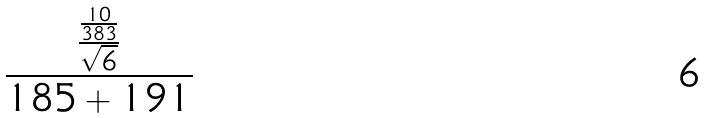<formula> <loc_0><loc_0><loc_500><loc_500>\frac { \frac { \frac { 1 0 } { 3 8 3 } } { \sqrt { 6 } } } { 1 8 5 + 1 9 1 }</formula> 